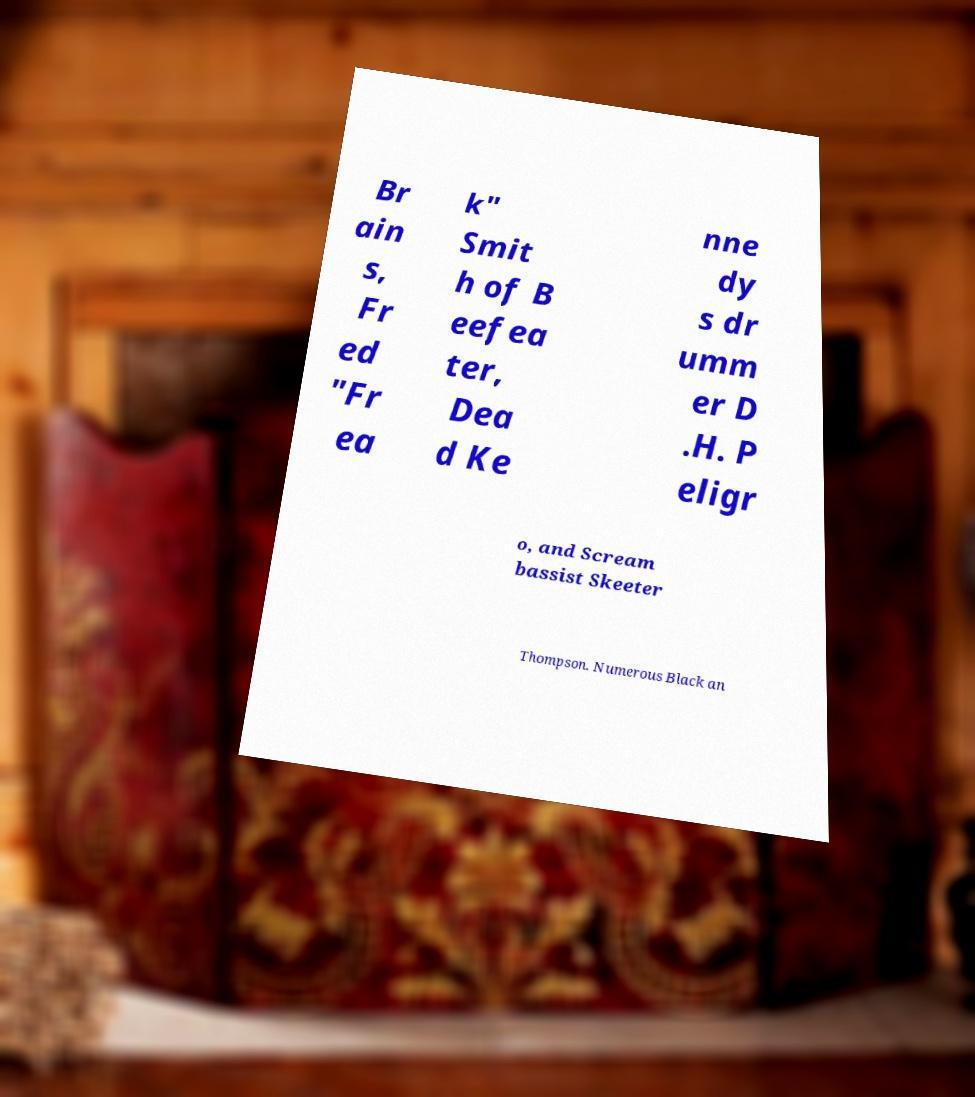Please identify and transcribe the text found in this image. Br ain s, Fr ed "Fr ea k" Smit h of B eefea ter, Dea d Ke nne dy s dr umm er D .H. P eligr o, and Scream bassist Skeeter Thompson. Numerous Black an 